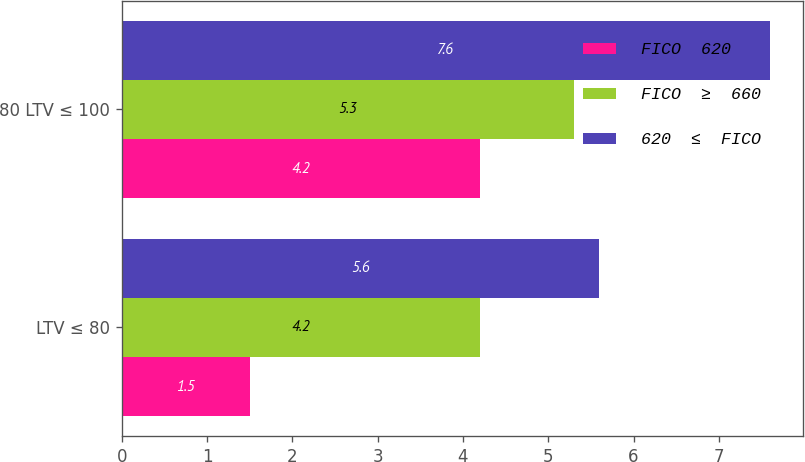Convert chart to OTSL. <chart><loc_0><loc_0><loc_500><loc_500><stacked_bar_chart><ecel><fcel>LTV ≤ 80<fcel>80 LTV ≤ 100<nl><fcel>FICO  620<fcel>1.5<fcel>4.2<nl><fcel>FICO  ≥  660<fcel>4.2<fcel>5.3<nl><fcel>620  ≤  FICO<fcel>5.6<fcel>7.6<nl></chart> 